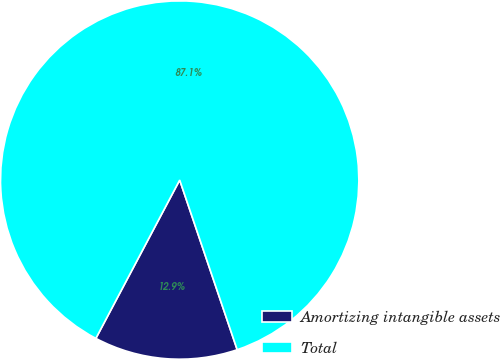Convert chart to OTSL. <chart><loc_0><loc_0><loc_500><loc_500><pie_chart><fcel>Amortizing intangible assets<fcel>Total<nl><fcel>12.95%<fcel>87.05%<nl></chart> 